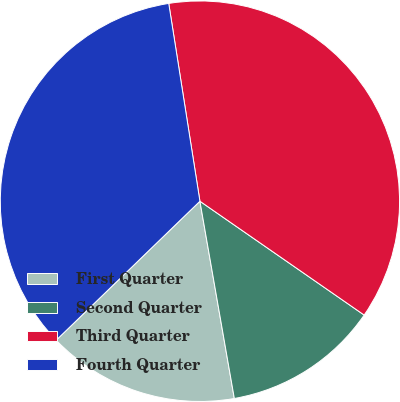Convert chart to OTSL. <chart><loc_0><loc_0><loc_500><loc_500><pie_chart><fcel>First Quarter<fcel>Second Quarter<fcel>Third Quarter<fcel>Fourth Quarter<nl><fcel>15.55%<fcel>12.62%<fcel>37.12%<fcel>34.71%<nl></chart> 